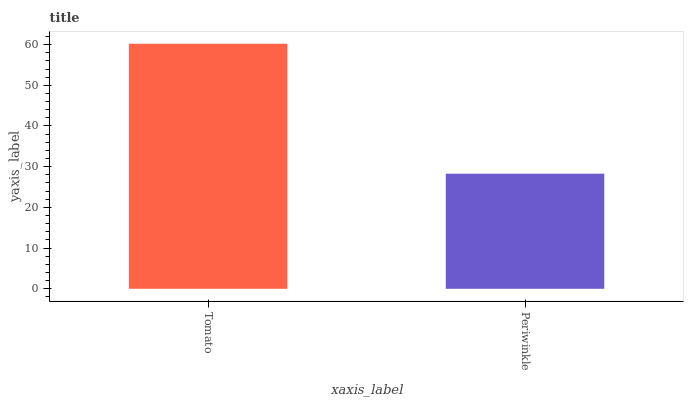Is Periwinkle the minimum?
Answer yes or no. Yes. Is Tomato the maximum?
Answer yes or no. Yes. Is Periwinkle the maximum?
Answer yes or no. No. Is Tomato greater than Periwinkle?
Answer yes or no. Yes. Is Periwinkle less than Tomato?
Answer yes or no. Yes. Is Periwinkle greater than Tomato?
Answer yes or no. No. Is Tomato less than Periwinkle?
Answer yes or no. No. Is Tomato the high median?
Answer yes or no. Yes. Is Periwinkle the low median?
Answer yes or no. Yes. Is Periwinkle the high median?
Answer yes or no. No. Is Tomato the low median?
Answer yes or no. No. 